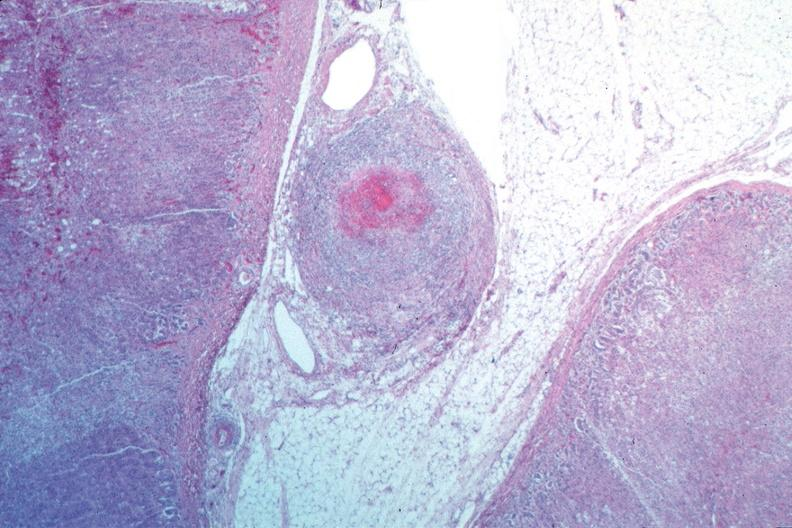what is present?
Answer the question using a single word or phrase. Cardiovascular 